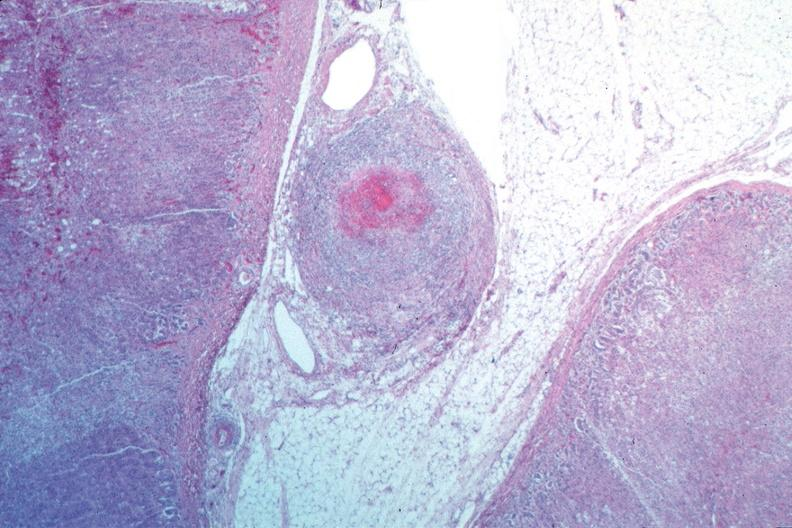what is present?
Answer the question using a single word or phrase. Cardiovascular 